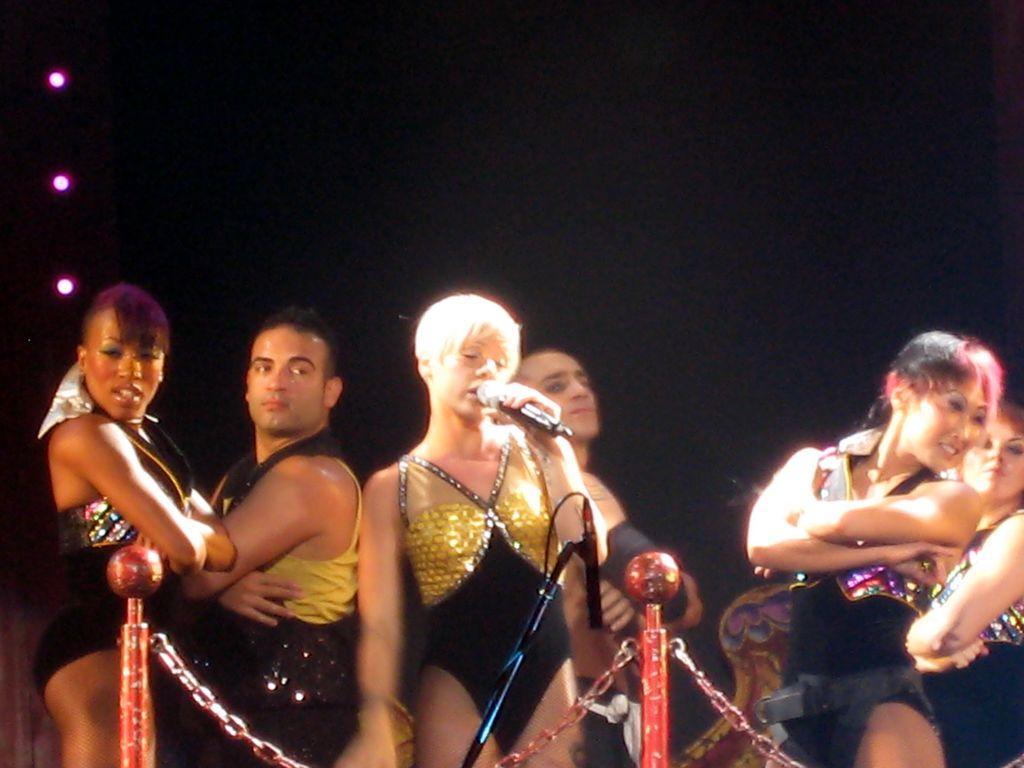In one or two sentences, can you explain what this image depicts? In this image we can see a group of people wearing dress are standing on the floor. One woman is holding a microphone in her hand. In the foreground we can see a group of poles and chains, a microphone placed on a stand. In the background we can see some lights. 